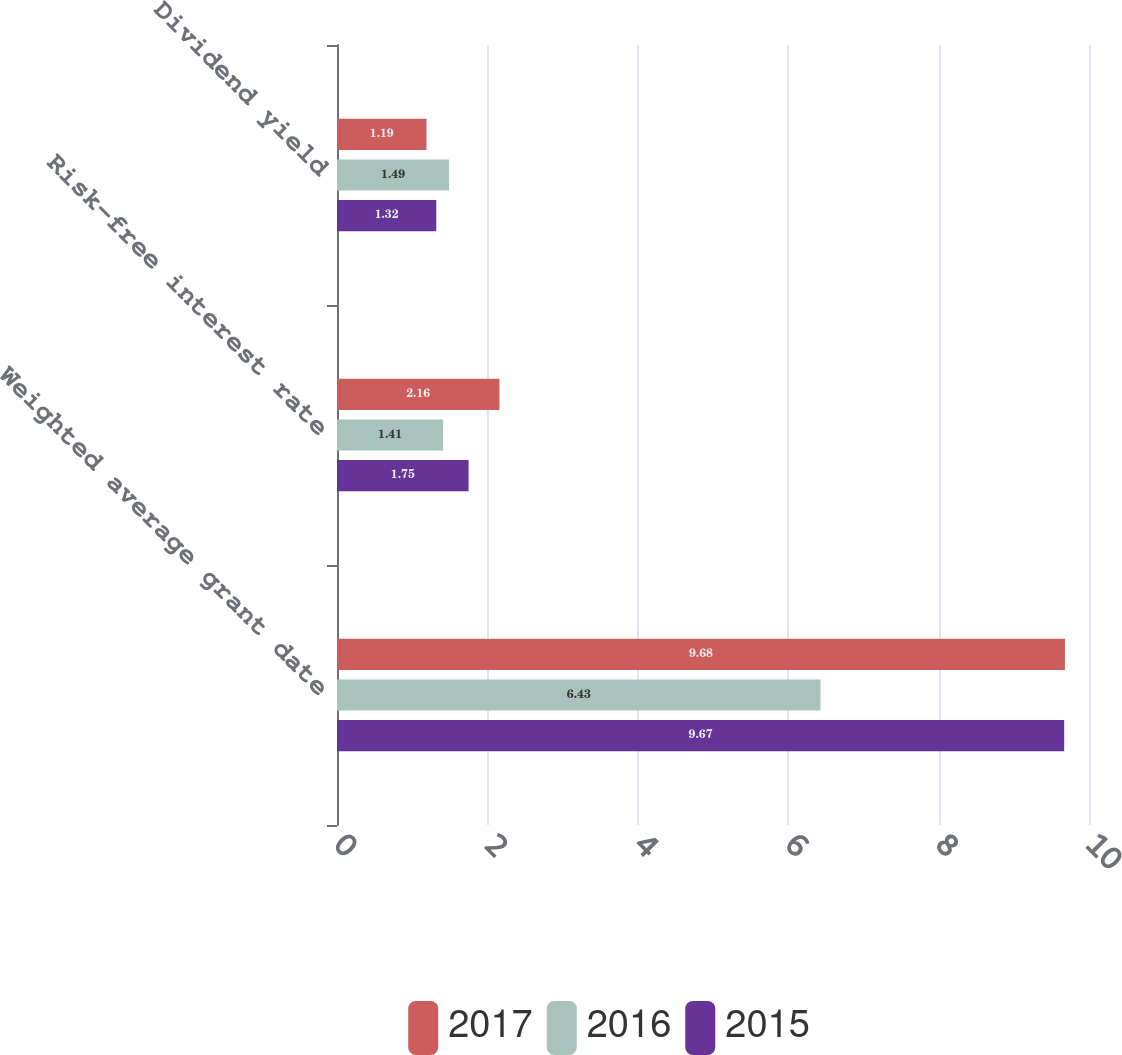Convert chart to OTSL. <chart><loc_0><loc_0><loc_500><loc_500><stacked_bar_chart><ecel><fcel>Weighted average grant date<fcel>Risk-free interest rate<fcel>Dividend yield<nl><fcel>2017<fcel>9.68<fcel>2.16<fcel>1.19<nl><fcel>2016<fcel>6.43<fcel>1.41<fcel>1.49<nl><fcel>2015<fcel>9.67<fcel>1.75<fcel>1.32<nl></chart> 